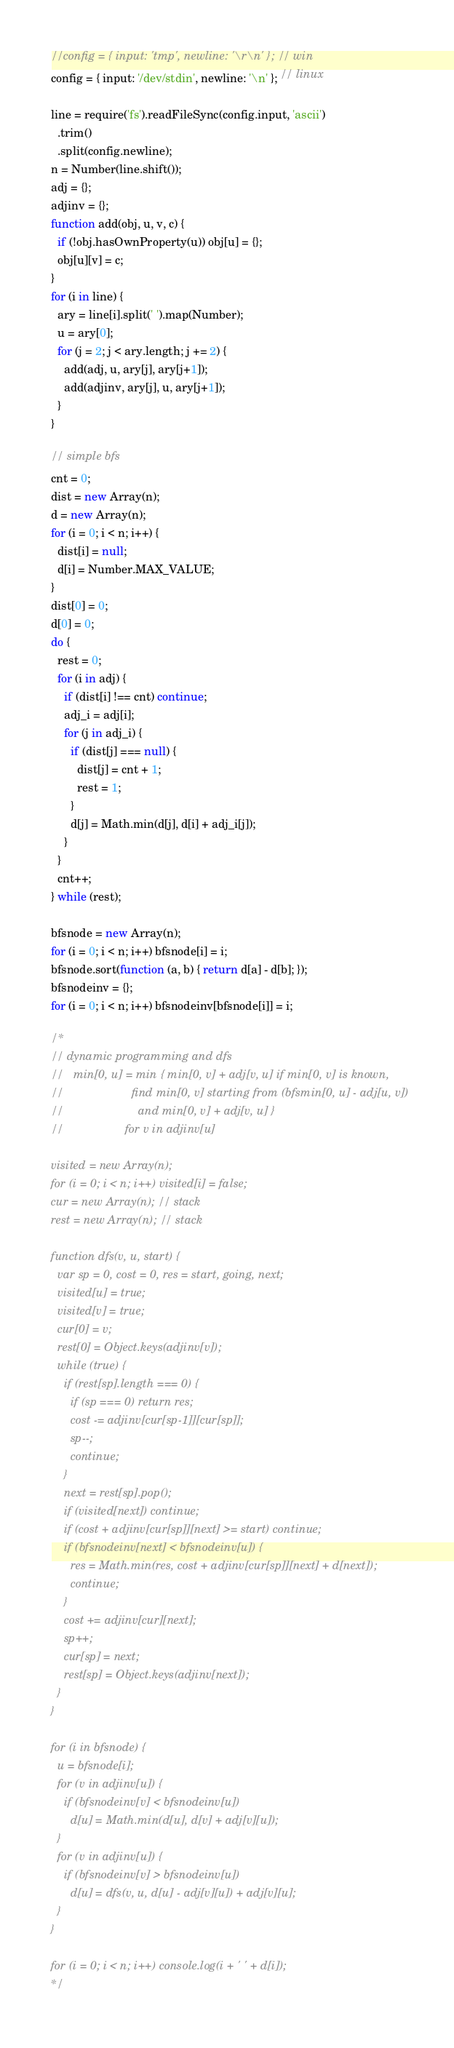Convert code to text. <code><loc_0><loc_0><loc_500><loc_500><_JavaScript_>//config = { input: 'tmp', newline: '\r\n' }; // win
config = { input: '/dev/stdin', newline: '\n' }; // linux

line = require('fs').readFileSync(config.input, 'ascii')
  .trim()
  .split(config.newline);
n = Number(line.shift());
adj = {};
adjinv = {};
function add(obj, u, v, c) {
  if (!obj.hasOwnProperty(u)) obj[u] = {};
  obj[u][v] = c;
}
for (i in line) {
  ary = line[i].split(' ').map(Number);
  u = ary[0];
  for (j = 2; j < ary.length; j += 2) {
    add(adj, u, ary[j], ary[j+1]);
    add(adjinv, ary[j], u, ary[j+1]);
  }
}

// simple bfs
cnt = 0;
dist = new Array(n);
d = new Array(n);
for (i = 0; i < n; i++) {
  dist[i] = null;
  d[i] = Number.MAX_VALUE;
}
dist[0] = 0;
d[0] = 0;
do {
  rest = 0;
  for (i in adj) {
    if (dist[i] !== cnt) continue;
    adj_i = adj[i];
    for (j in adj_i) {
      if (dist[j] === null) {
        dist[j] = cnt + 1;
        rest = 1;
      }
      d[j] = Math.min(d[j], d[i] + adj_i[j]);
    }
  }
  cnt++;
} while (rest);

bfsnode = new Array(n);
for (i = 0; i < n; i++) bfsnode[i] = i;
bfsnode.sort(function (a, b) { return d[a] - d[b]; });
bfsnodeinv = {};
for (i = 0; i < n; i++) bfsnodeinv[bfsnode[i]] = i;

/*
// dynamic programming and dfs
//   min[0, u] = min { min[0, v] + adj[v, u] if min[0, v] is known,
//                     find min[0, v] starting from (bfsmin[0, u] - adj[u, v])
//                       and min[0, v] + adj[v, u] }
//                   for v in adjinv[u]

visited = new Array(n);
for (i = 0; i < n; i++) visited[i] = false;
cur = new Array(n); // stack
rest = new Array(n); // stack

function dfs(v, u, start) {
  var sp = 0, cost = 0, res = start, going, next;
  visited[u] = true;
  visited[v] = true;
  cur[0] = v;
  rest[0] = Object.keys(adjinv[v]);
  while (true) {
    if (rest[sp].length === 0) {
      if (sp === 0) return res;
      cost -= adjinv[cur[sp-1]][cur[sp]];
      sp--;
      continue;
    }
    next = rest[sp].pop();
    if (visited[next]) continue;
    if (cost + adjinv[cur[sp]][next] >= start) continue;
    if (bfsnodeinv[next] < bfsnodeinv[u]) {
      res = Math.min(res, cost + adjinv[cur[sp]][next] + d[next]);
      continue;
    }
    cost += adjinv[cur][next];
    sp++;
    cur[sp] = next;
    rest[sp] = Object.keys(adjinv[next]);
  }
}

for (i in bfsnode) {
  u = bfsnode[i];
  for (v in adjinv[u]) {
    if (bfsnodeinv[v] < bfsnodeinv[u])
      d[u] = Math.min(d[u], d[v] + adj[v][u]);
  }
  for (v in adjinv[u]) {
    if (bfsnodeinv[v] > bfsnodeinv[u])
      d[u] = dfs(v, u, d[u] - adj[v][u]) + adj[v][u];
  }
}

for (i = 0; i < n; i++) console.log(i + ' ' + d[i]);
*/</code> 